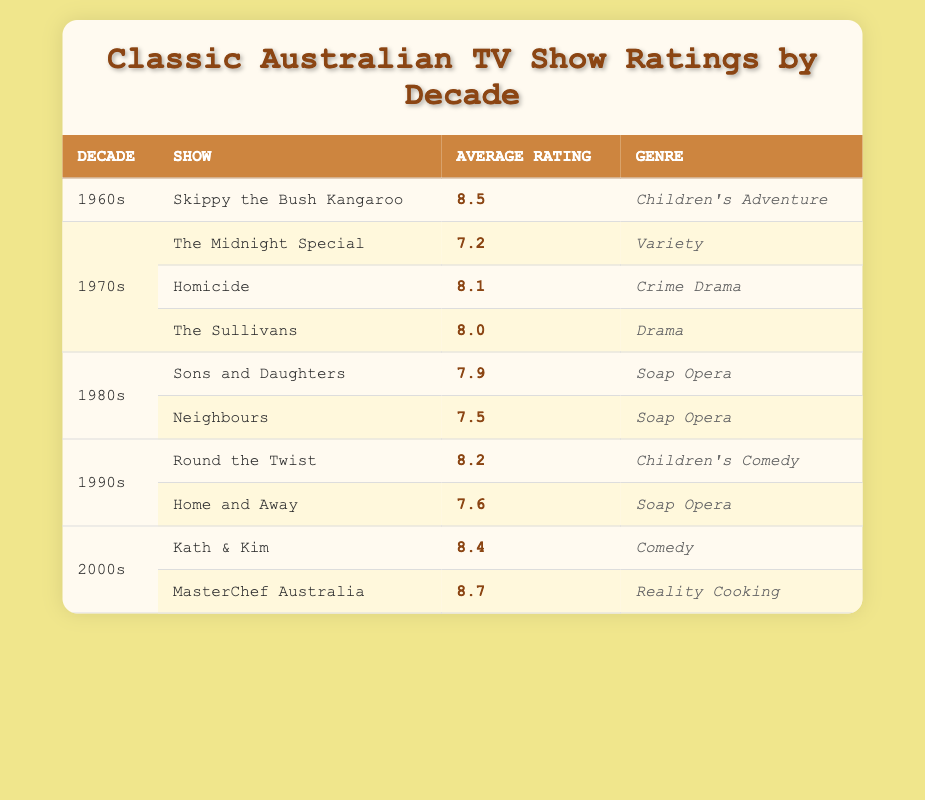What is the average rating of "Skippy the Bush Kangaroo"? The table lists "Skippy the Bush Kangaroo" under the 1960s decade with an average rating of 8.5. Therefore, that is the answer.
Answer: 8.5 Which show from the 1970s has the highest average rating? Reviewing the ratings of the shows listed under the 1970s, "Homicide" has the highest average rating at 8.1, compared to "The Sullivans" at 8.0 and "The Midnight Special" at 7.2.
Answer: Homicide How many shows from the 1980s are featured in the table? There are two shows from the 1980s listed: "Sons and Daughters" and "Neighbours."
Answer: 2 Is "MasterChef Australia" rated higher than "Kath & Kim"? Comparing the average ratings, "MasterChef Australia" has an average rating of 8.7 while "Kath & Kim" has a rating of 8.4. Therefore, "MasterChef Australia" is rated higher.
Answer: Yes What is the difference in average ratings between the highest-rated show of the 2000s and the lowest-rated show of the 1970s? "MasterChef Australia" is the highest-rated show of the 2000s with a rating of 8.7. The lowest-rated show of the 1970s is "The Midnight Special," which has a rating of 7.2. The difference is 8.7 - 7.2 = 1.5.
Answer: 1.5 What percentage of the shows in the 1990s have a rating above 8? There are two shows in the 1990s: "Round the Twist" with a rating of 8.2 and "Home and Away" with a rating of 7.6. Out of the two shows, only "Round the Twist" has a rating above 8, which is 50%.
Answer: 50% Which genre has the lowest average rating across all decades in the table? To find this, we look at the genres and their respective ratings: "Variety" has 7.2, "Soap Opera" averages (7.9 + 7.5 + 7.6) / 3 = 7.67, "Children's Adventure" is 8.5, "Drama" is 8.0, "Crime Drama" is 8.1, "Children's Comedy" is 8.2, and "Comedy" is 8.4. The lowest is "Variety" at 7.2.
Answer: Variety Are there more shows in the 2000s than in the 1960s? The table lists two shows from the 2000s ("Kath & Kim" and "MasterChef Australia") and only one from the 1960s ("Skippy the Bush Kangaroo"). Therefore, there are more shows in the 2000s.
Answer: Yes What is the average rating of shows in the 1980s? The ratings for the shows in the 1980s are "Sons and Daughters" at 7.9 and "Neighbours" at 7.5. The average rating is (7.9 + 7.5) / 2 = 7.7.
Answer: 7.7 